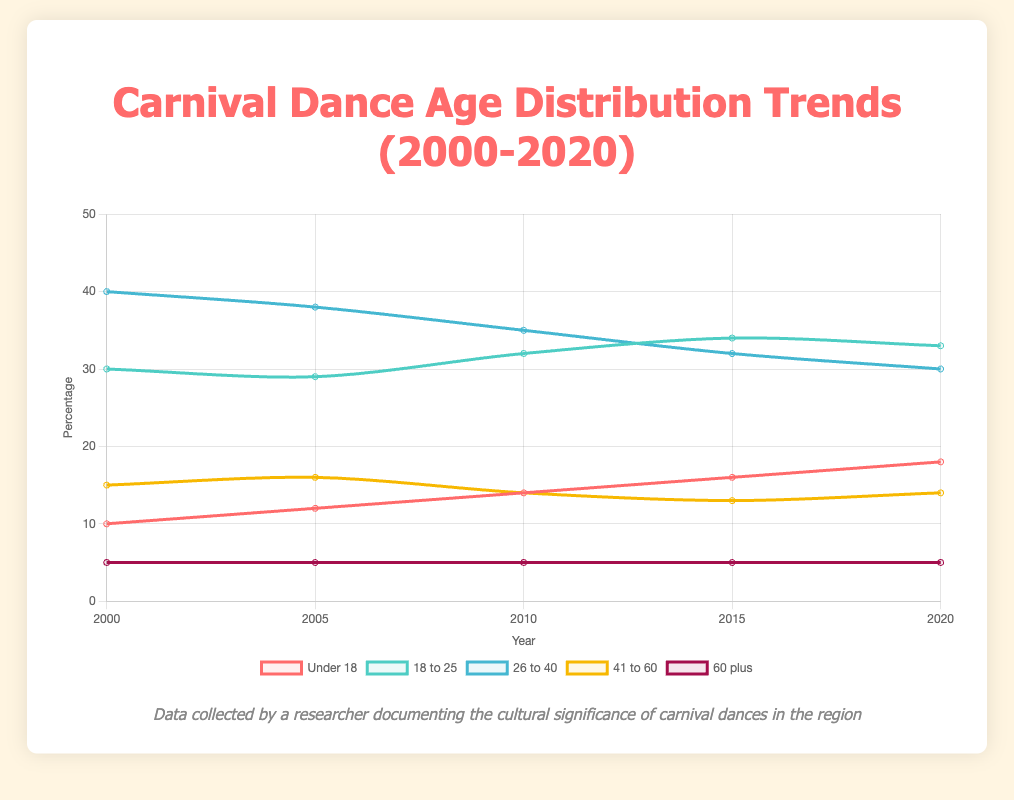What was the trend for participants under 18 from 2000 to 2020? The percentage of participants under 18 has increased over the years. In 2000, it was 10%, and it gradually rose to 18% in 2020. This shows a consistent upward trend.
Answer: Increased How does the number of participants aged 26 to 40 in 2000 compare to those in 2020? The percentage of participants aged 26 to 40 decreased over the period. In 2000, it was 40%, but by 2020, it had dropped to 30%.
Answer: Decreased Which age group remained constant from 2000 to 2020? The age group "60 plus" remained constant over these years. It was 5% in 2000 and stayed the same through to 2020.
Answer: 60 plus What is the average percentage of participants aged 41 to 60 across all the years? The percentage of participants aged 41 to 60 for each year is (15, 16, 14, 13, 14). Summing these values gives 72, and the average is calculated as 72/5 = 14.4%.
Answer: 14.4% Which age group has the highest percentage in 2015? In 2015, the age group with the highest percentage was "18 to 25" with 34%.
Answer: 18 to 25 What is the difference in percentage between participants aged 18 to 25 and 41 to 60 in 2020? In 2020, participants aged 18 to 25 accounted for 33%, while those aged 41 to 60 were 14%. The difference is 33 - 14 = 19%.
Answer: 19% Between which two consecutive years did participants under 18 see the largest percentage increase? The largest increase for participants under 18 occurred between 2015 and 2020. The percentage increased from 16% in 2015 to 18% in 2020, which is a difference of 2%.
Answer: 2015 and 2020 What is the median percentage for participants aged 26 to 40 across the given years? The percentages for participants aged 26 to 40 are (40, 38, 35, 32, 30). When arranged in ascending order: (30, 32, 35, 38, 40), the middle value or median is 35%.
Answer: 35% Comparing the percentage changes, did the age group 18 to 25 increase or decrease from 2000 to 2020? In 2000, the percentage was 30%, and in 2020 it was 33%. Thus, there was an increase.
Answer: Increased What is the total percentage change for participants aged 26 to 40 from 2000 to 2020? The percentage for participants aged 26 to 40 was 40% in 2000 and 30% in 2020. The total change is calculated as 40 - 30 = 10%.
Answer: 10% 